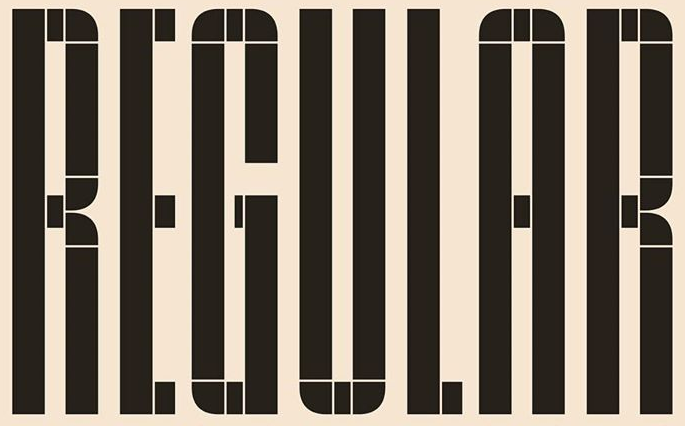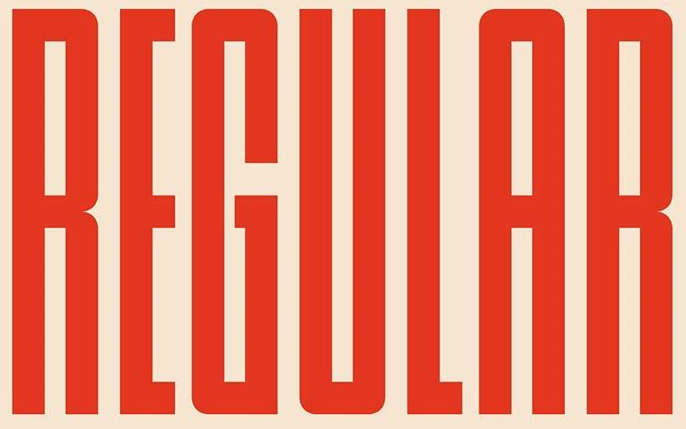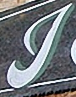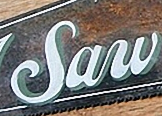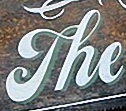What text appears in these images from left to right, separated by a semicolon? REGULAR; REGULAR; J; Saw; The 